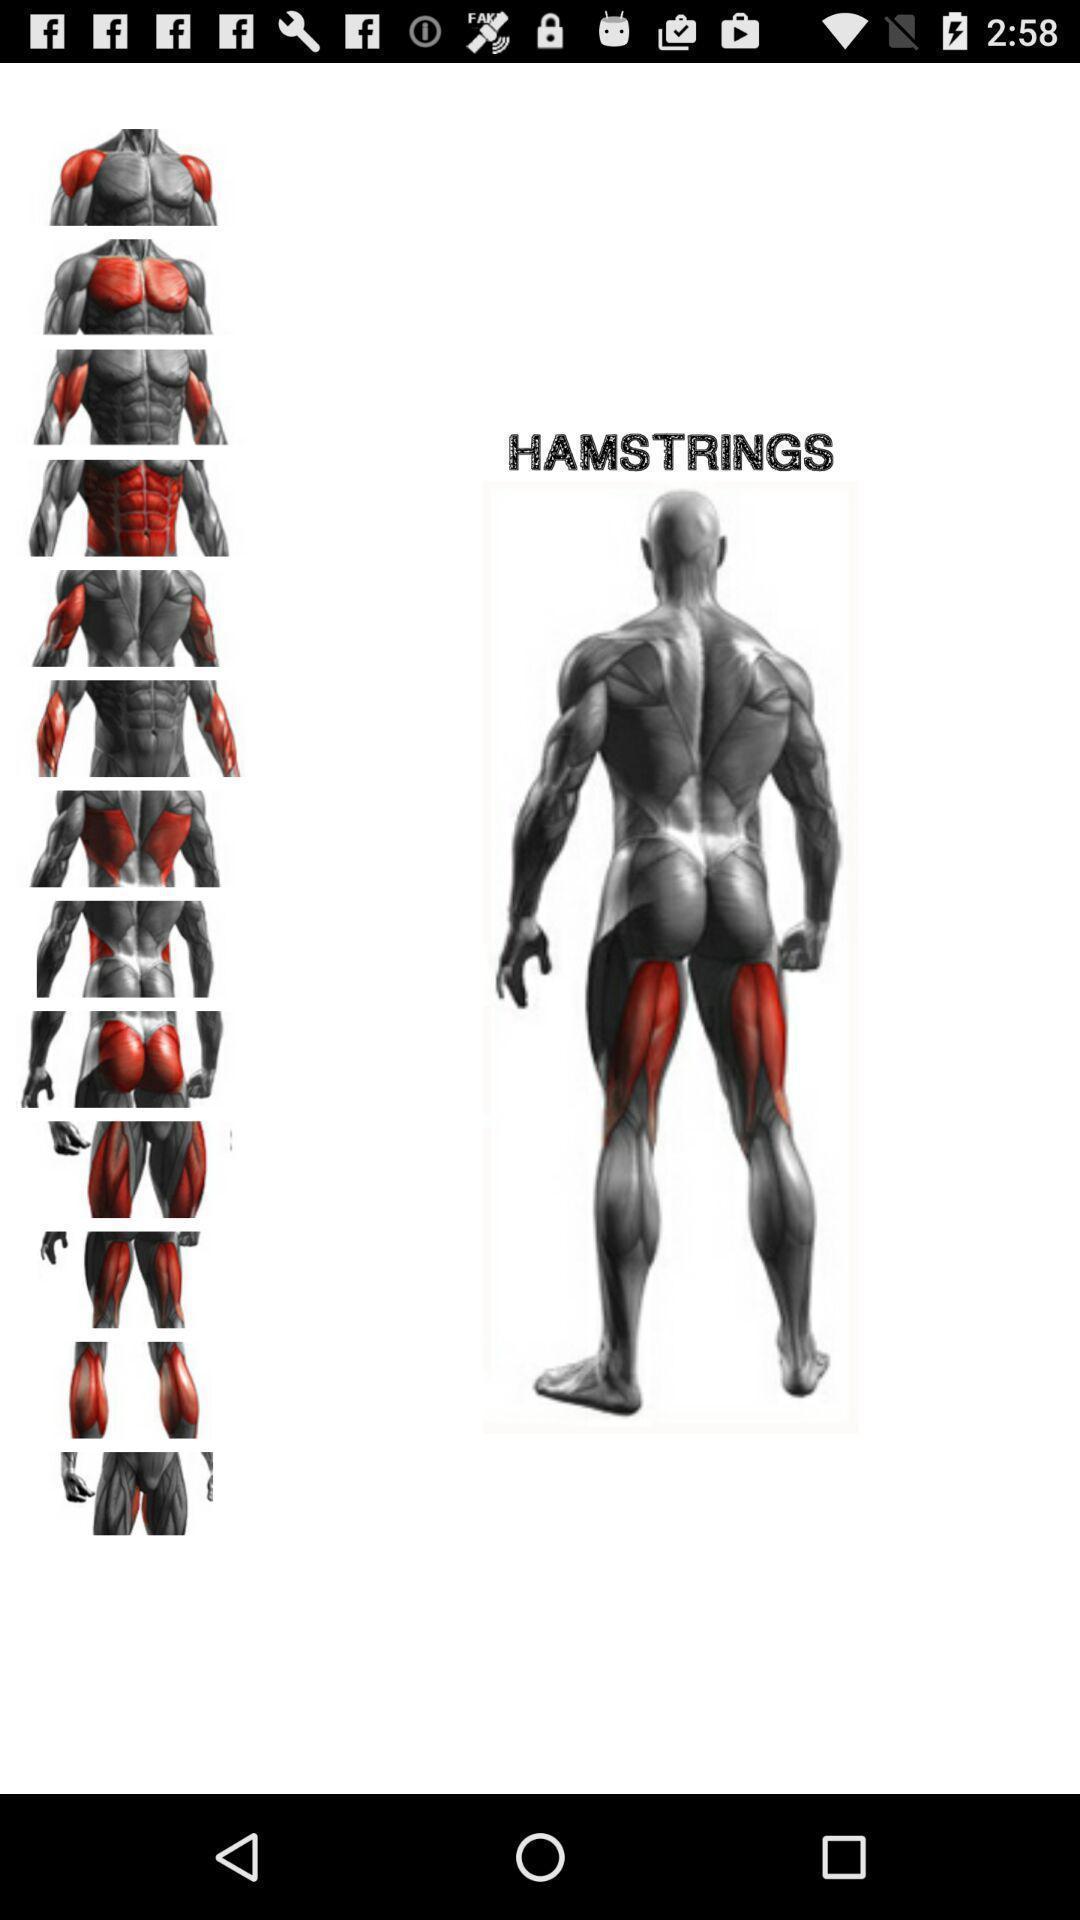What is the overall content of this screenshot? Screen displaying body building of body parts. 